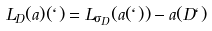Convert formula to latex. <formula><loc_0><loc_0><loc_500><loc_500>L _ { D } ( a ) ( \ell ) = L _ { \sigma _ { D } } ( a ( \ell ) ) - a ( D \ell )</formula> 